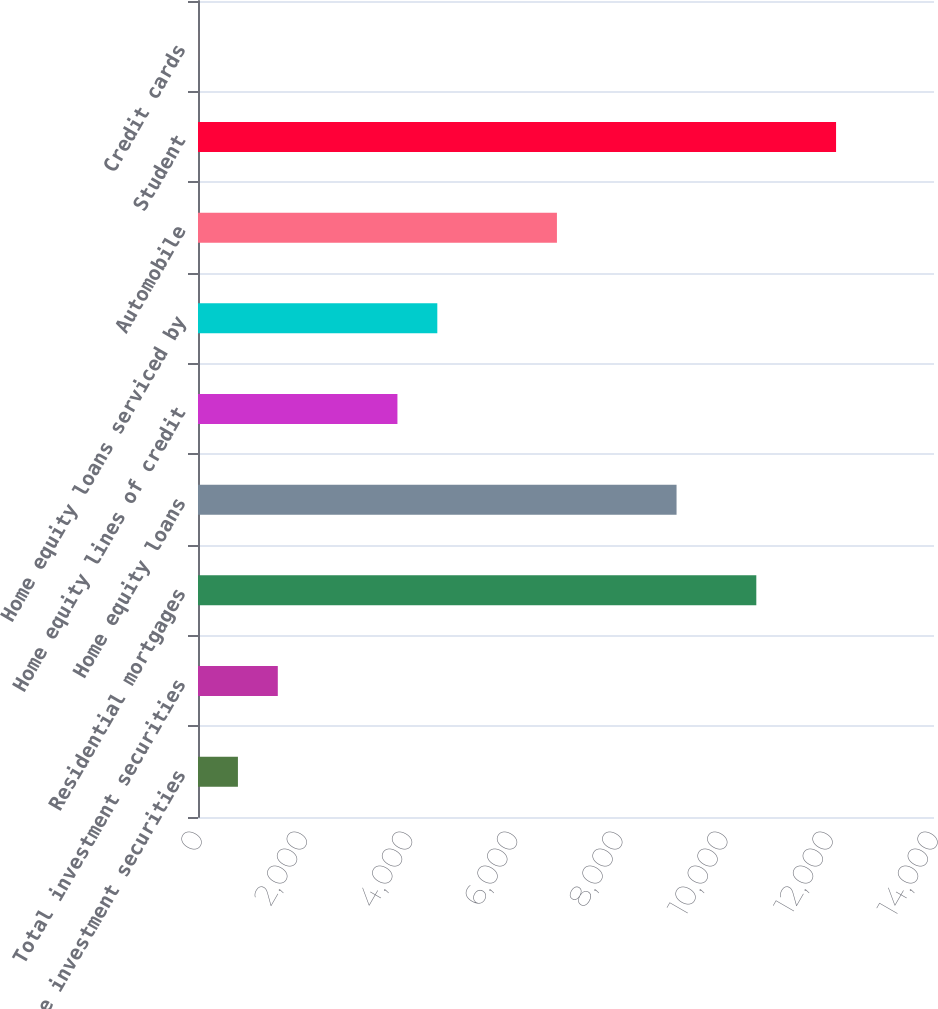Convert chart. <chart><loc_0><loc_0><loc_500><loc_500><bar_chart><fcel>Taxable investment securities<fcel>Total investment securities<fcel>Residential mortgages<fcel>Home equity loans<fcel>Home equity lines of credit<fcel>Home equity loans serviced by<fcel>Automobile<fcel>Student<fcel>Credit cards<nl><fcel>759.5<fcel>1518<fcel>10620<fcel>9103<fcel>3793.5<fcel>4552<fcel>6827.5<fcel>12137<fcel>1<nl></chart> 